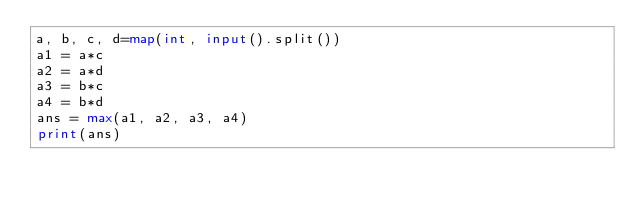Convert code to text. <code><loc_0><loc_0><loc_500><loc_500><_Python_>a, b, c, d=map(int, input().split())
a1 = a*c
a2 = a*d
a3 = b*c
a4 = b*d
ans = max(a1, a2, a3, a4)
print(ans)</code> 